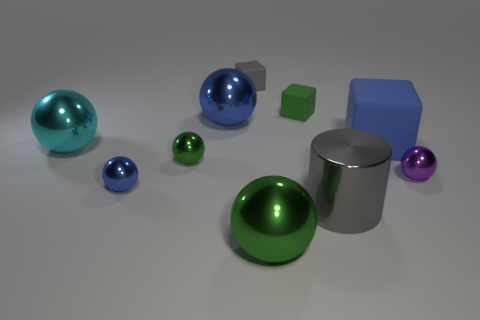Subtract 2 spheres. How many spheres are left? 4 Subtract all cyan balls. How many balls are left? 5 Subtract all tiny purple balls. How many balls are left? 5 Subtract all purple cubes. Subtract all brown cylinders. How many cubes are left? 3 Subtract all spheres. How many objects are left? 4 Add 4 purple shiny spheres. How many purple shiny spheres exist? 5 Subtract 1 green spheres. How many objects are left? 9 Subtract all big green metallic balls. Subtract all tiny green rubber objects. How many objects are left? 8 Add 5 large cyan shiny things. How many large cyan shiny things are left? 6 